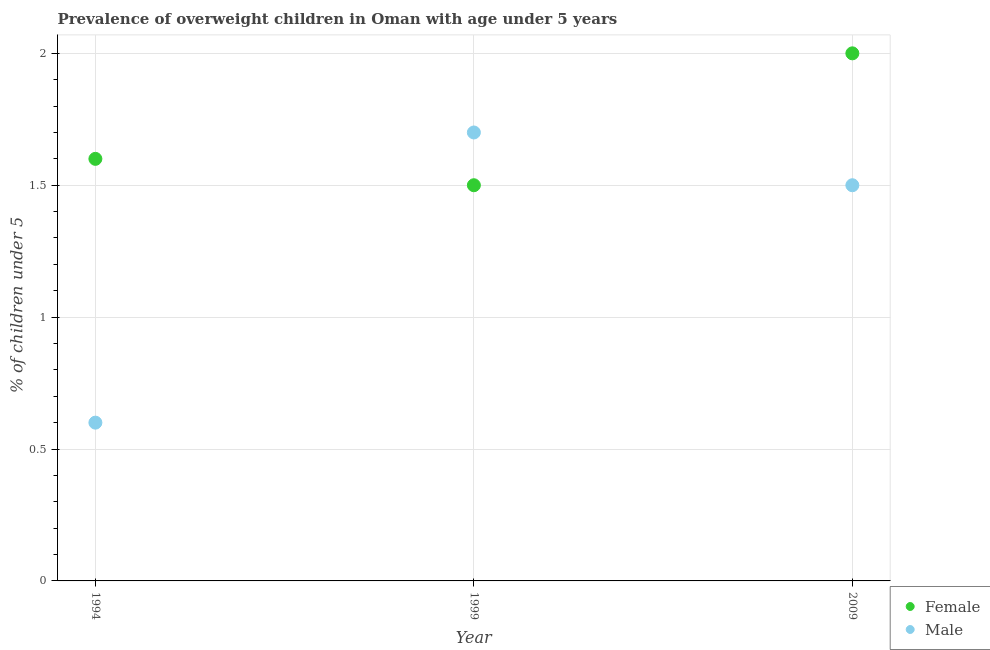How many different coloured dotlines are there?
Your answer should be very brief. 2. Is the number of dotlines equal to the number of legend labels?
Provide a succinct answer. Yes. Across all years, what is the maximum percentage of obese male children?
Provide a short and direct response. 1.7. Across all years, what is the minimum percentage of obese male children?
Your answer should be compact. 0.6. In which year was the percentage of obese male children maximum?
Ensure brevity in your answer.  1999. What is the total percentage of obese female children in the graph?
Give a very brief answer. 5.1. What is the difference between the percentage of obese female children in 1994 and that in 2009?
Provide a succinct answer. -0.4. What is the difference between the percentage of obese male children in 1994 and the percentage of obese female children in 1999?
Keep it short and to the point. -0.9. What is the average percentage of obese female children per year?
Provide a succinct answer. 1.7. In the year 1999, what is the difference between the percentage of obese male children and percentage of obese female children?
Offer a terse response. 0.2. In how many years, is the percentage of obese male children greater than 0.6 %?
Provide a short and direct response. 3. What is the ratio of the percentage of obese female children in 1994 to that in 1999?
Give a very brief answer. 1.07. Is the difference between the percentage of obese male children in 1994 and 1999 greater than the difference between the percentage of obese female children in 1994 and 1999?
Your response must be concise. No. What is the difference between the highest and the second highest percentage of obese male children?
Your answer should be very brief. 0.2. What is the difference between the highest and the lowest percentage of obese male children?
Keep it short and to the point. 1.1. In how many years, is the percentage of obese female children greater than the average percentage of obese female children taken over all years?
Make the answer very short. 1. Is the sum of the percentage of obese female children in 1999 and 2009 greater than the maximum percentage of obese male children across all years?
Provide a short and direct response. Yes. Is the percentage of obese male children strictly greater than the percentage of obese female children over the years?
Offer a terse response. No. Is the percentage of obese male children strictly less than the percentage of obese female children over the years?
Make the answer very short. No. What is the difference between two consecutive major ticks on the Y-axis?
Provide a succinct answer. 0.5. Does the graph contain any zero values?
Offer a very short reply. No. What is the title of the graph?
Provide a succinct answer. Prevalence of overweight children in Oman with age under 5 years. Does "Netherlands" appear as one of the legend labels in the graph?
Provide a short and direct response. No. What is the label or title of the X-axis?
Your answer should be very brief. Year. What is the label or title of the Y-axis?
Your answer should be compact.  % of children under 5. What is the  % of children under 5 of Female in 1994?
Ensure brevity in your answer.  1.6. What is the  % of children under 5 in Male in 1994?
Give a very brief answer. 0.6. What is the  % of children under 5 in Male in 1999?
Provide a short and direct response. 1.7. What is the  % of children under 5 in Male in 2009?
Keep it short and to the point. 1.5. Across all years, what is the maximum  % of children under 5 of Female?
Keep it short and to the point. 2. Across all years, what is the maximum  % of children under 5 of Male?
Your answer should be very brief. 1.7. Across all years, what is the minimum  % of children under 5 in Male?
Your answer should be very brief. 0.6. What is the difference between the  % of children under 5 in Male in 1994 and that in 2009?
Your response must be concise. -0.9. What is the difference between the  % of children under 5 of Male in 1999 and that in 2009?
Ensure brevity in your answer.  0.2. What is the average  % of children under 5 of Female per year?
Provide a short and direct response. 1.7. What is the average  % of children under 5 in Male per year?
Your answer should be very brief. 1.27. In the year 2009, what is the difference between the  % of children under 5 of Female and  % of children under 5 of Male?
Your answer should be very brief. 0.5. What is the ratio of the  % of children under 5 in Female in 1994 to that in 1999?
Your answer should be very brief. 1.07. What is the ratio of the  % of children under 5 of Male in 1994 to that in 1999?
Ensure brevity in your answer.  0.35. What is the ratio of the  % of children under 5 of Female in 1994 to that in 2009?
Keep it short and to the point. 0.8. What is the ratio of the  % of children under 5 of Female in 1999 to that in 2009?
Make the answer very short. 0.75. What is the ratio of the  % of children under 5 in Male in 1999 to that in 2009?
Offer a very short reply. 1.13. 